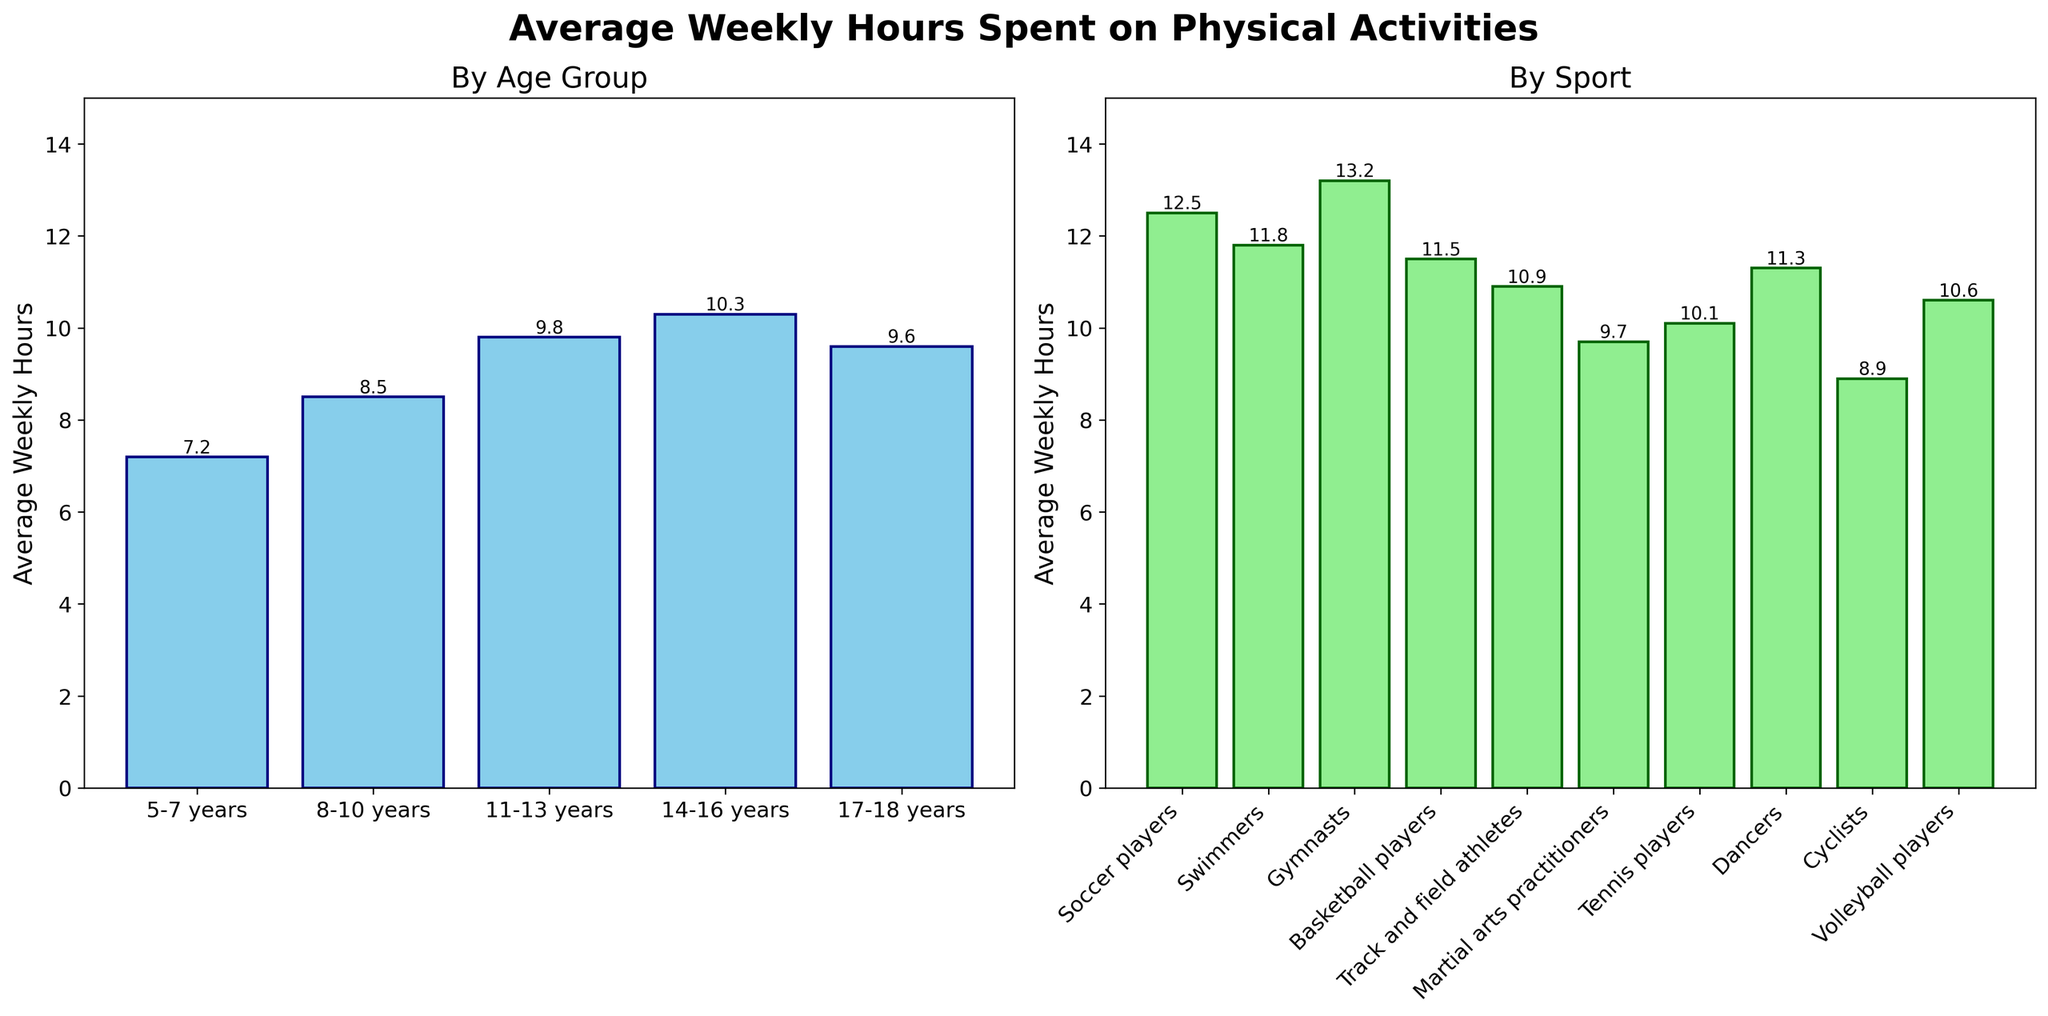what age group spends the most average weekly hours on physical activities? According to the left bar chart, the age group 14-16 years spends the most average weekly hours on physical activities, with a value of 10.3 hours per week.
Answer: 14-16 years which sport has the highest average weekly hours spent by children? According to the right bar chart, gymnasts spend the highest average weekly hours on physical activities, with a value of 13.2 hours per week.
Answer: Gymnasts how much more time do basketball players spend on physical activities than cyclists on average each week? The average weekly hours for basketball players is 11.5 and for cyclists is 8.9. The difference is 11.5 - 8.9 = 2.6 hours.
Answer: 2.6 hours what is the difference in average weekly hours spent on physical activities between the 11-13 years and the 14-16 years age groups? The average weekly hours for 11-13 years is 9.8, and for 14-16 years is 10.3. The difference is 10.3 - 9.8 = 0.5 hours.
Answer: 0.5 hours what is the total average weekly hours spent on physical activities by tennis players and volleyball players combined? The average weekly hours for tennis players is 10.1 and for volleyball players is 10.6. The total is 10.1 + 10.6 = 20.7 hours.
Answer: 20.7 hours which has a higher average weekly hours, martial arts practitioners or dancers? Comparing the bar heights, dancers have an average of 11.3 weekly hours, and martial arts practitioners have 9.7. Hence, dancers spend more time.
Answer: Dancers what is the average weekly hours spent on physical activities for children aged 17-18 years and swimmers combined? The average weekly hours for 17-18 years is 9.6, and for swimmers, it is 11.8. The combined average is (9.6 + 11.8) / 2 = 10.7 hours.
Answer: 10.7 hours what two sports have the closest average weekly hours spent on physical activities, and what is their average? Tennis players and volleyball players have the closest average weekly hours with 10.1 and 10.6 hours, respectively. Their average is (10.1 + 10.6) / 2 = 10.35 hours.
Answer: Tennis players and volleyball players, 10.35 hours of the age groups, which has the least average weekly hours spent on physical activities and what is it? According to the left bar chart, the 5-7 years age group has the least average weekly hours on physical activities, with 7.2 hours per week.
Answer: 5-7 years, 7.2 hours overall, do children spend more average weekly hours on sports or based on age groups? By visually comparing the total height of the bars in both charts, children spend more average weekly hours on sports categories (as indicated by the generally taller bars) than on age groups.
Answer: Sports 